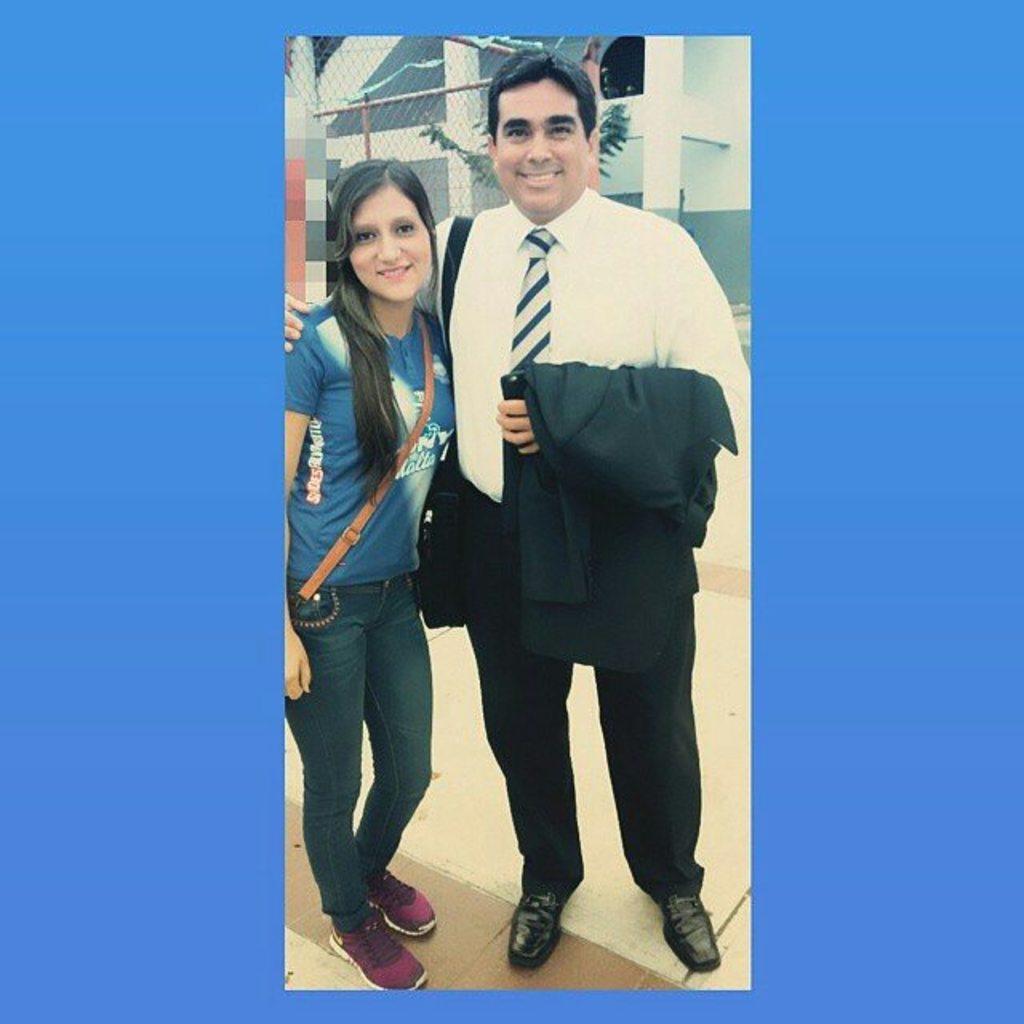Describe this image in one or two sentences. In this picture I can observe a man and a woman standing on the floor. Both of them are smiling. Behind them I can observe a fence. In the background there is a building. 